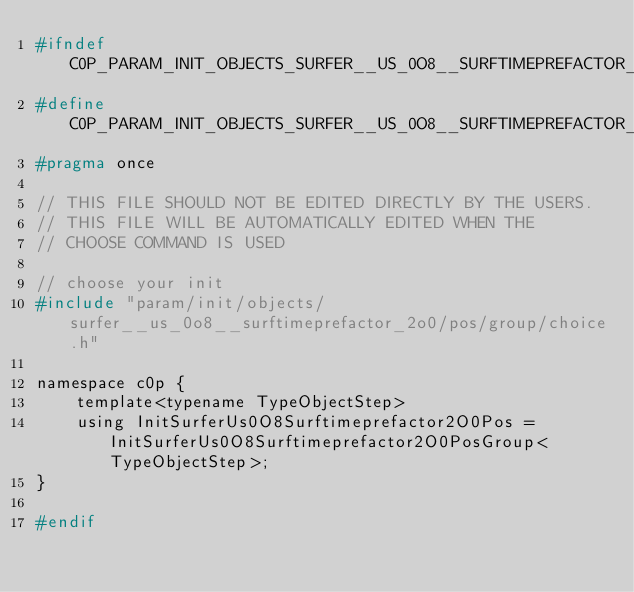Convert code to text. <code><loc_0><loc_0><loc_500><loc_500><_C_>#ifndef C0P_PARAM_INIT_OBJECTS_SURFER__US_0O8__SURFTIMEPREFACTOR_2O0_POS_CHOICE_H
#define C0P_PARAM_INIT_OBJECTS_SURFER__US_0O8__SURFTIMEPREFACTOR_2O0_POS_CHOICE_H
#pragma once

// THIS FILE SHOULD NOT BE EDITED DIRECTLY BY THE USERS.
// THIS FILE WILL BE AUTOMATICALLY EDITED WHEN THE
// CHOOSE COMMAND IS USED

// choose your init
#include "param/init/objects/surfer__us_0o8__surftimeprefactor_2o0/pos/group/choice.h"

namespace c0p {
    template<typename TypeObjectStep>
    using InitSurferUs0O8Surftimeprefactor2O0Pos = InitSurferUs0O8Surftimeprefactor2O0PosGroup<TypeObjectStep>;
}

#endif
</code> 